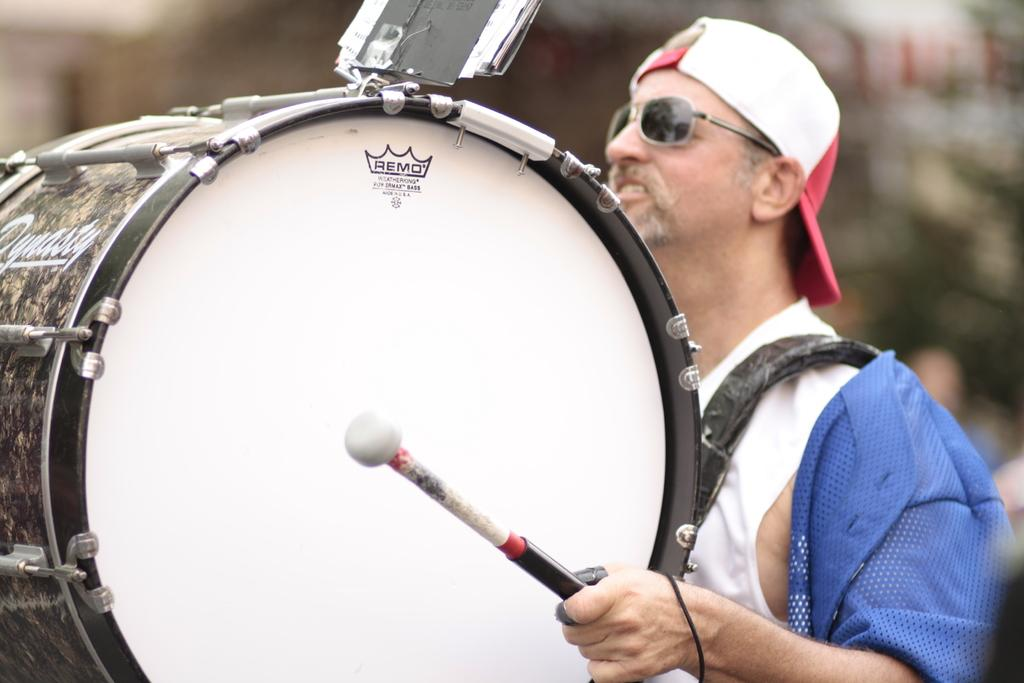What is the person in the image doing? The person is playing a drum. What is the person wearing on their upper body? The person is wearing a blue coat. What is the person wearing on their lower body? The person is wearing a white dress. What type of headwear is the person wearing? The person is wearing a cap. What type of pies can be seen on the table in the image? There is no table or pies present in the image; it features a person playing a drum. 